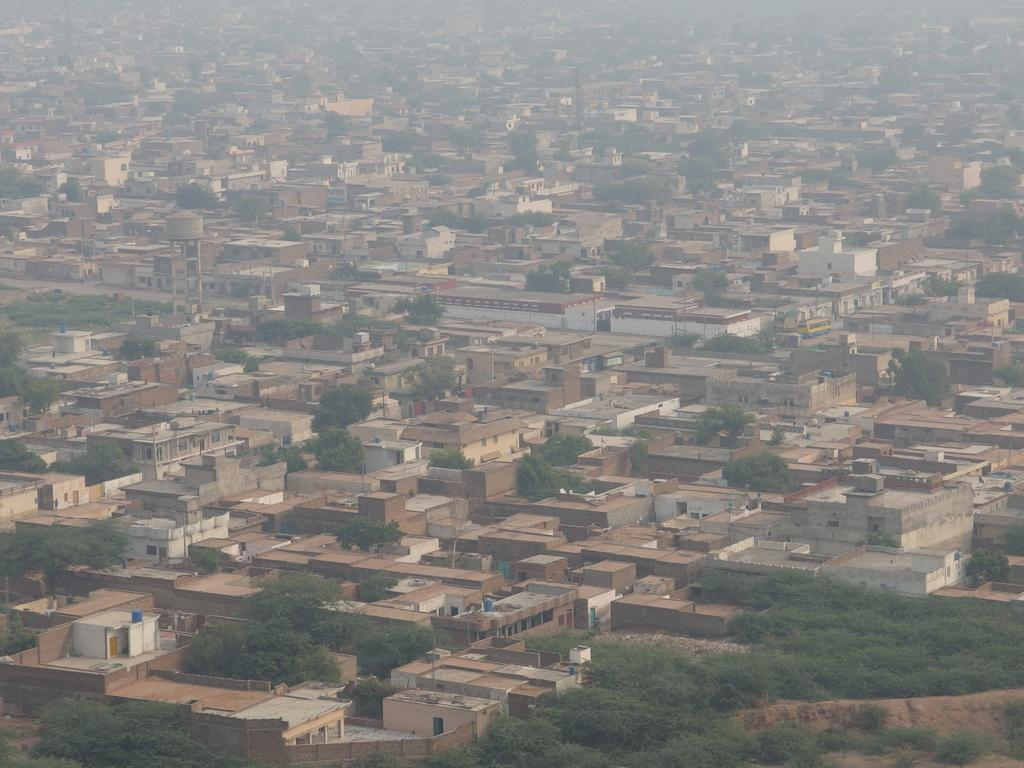What type of structures can be seen in the image? There are houses in the image. What type of vegetation is present in the image? There are trees in the image. Can you see any goats grazing on the trees in the image? There are no goats present in the image, and the trees are not being grazed upon. Is there any popcorn falling from the sky in the image? There is no popcorn present in the image, nor is it falling from the sky. 